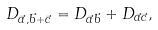Convert formula to latex. <formula><loc_0><loc_0><loc_500><loc_500>D _ { \vec { a } , \vec { b } + \vec { c } } = D _ { \vec { a } \vec { b } } + D _ { \vec { a } \vec { c } } ,</formula> 